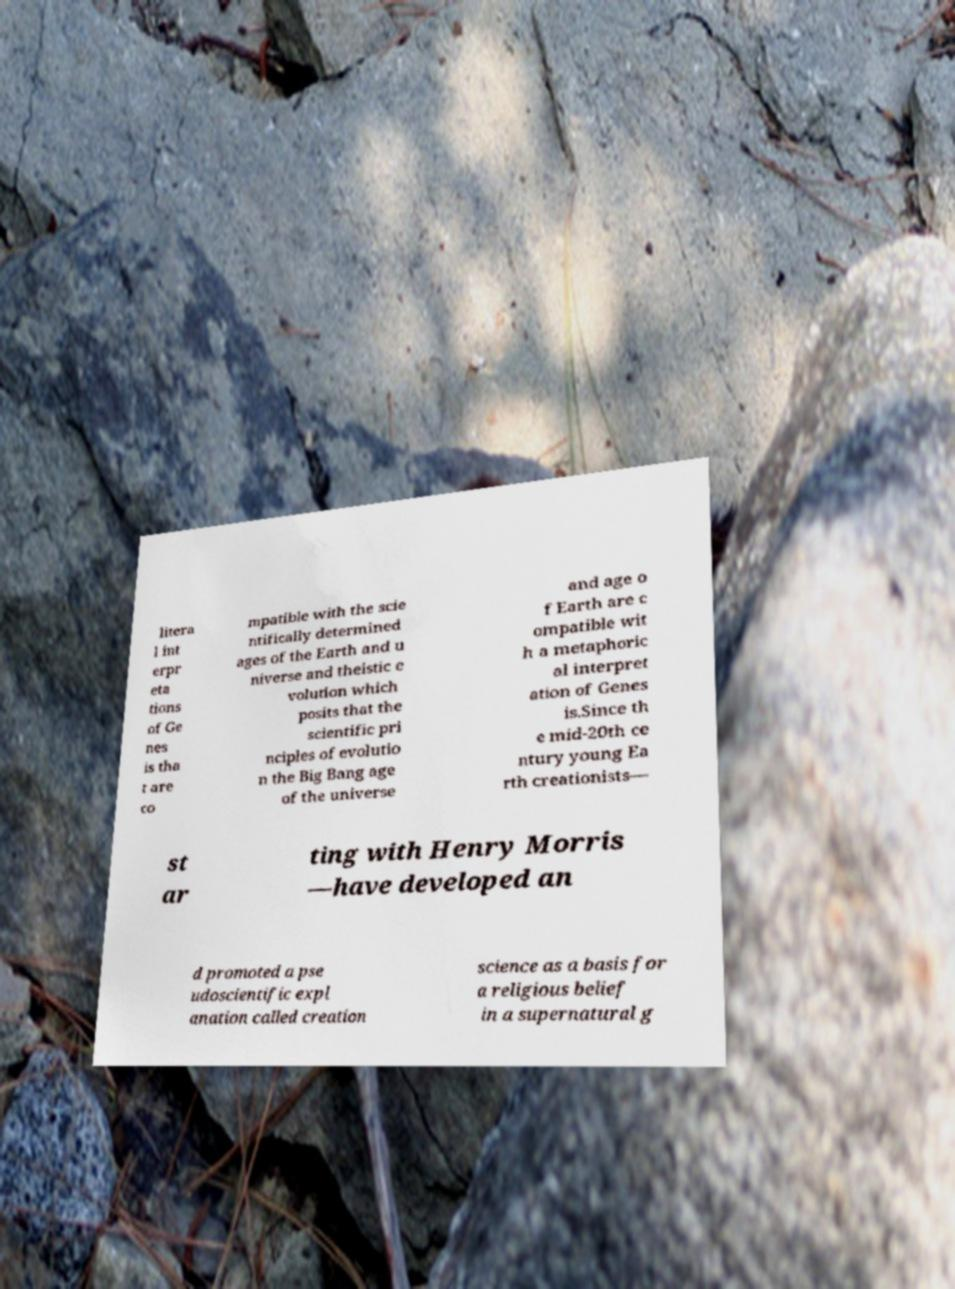There's text embedded in this image that I need extracted. Can you transcribe it verbatim? litera l int erpr eta tions of Ge nes is tha t are co mpatible with the scie ntifically determined ages of the Earth and u niverse and theistic e volution which posits that the scientific pri nciples of evolutio n the Big Bang age of the universe and age o f Earth are c ompatible wit h a metaphoric al interpret ation of Genes is.Since th e mid-20th ce ntury young Ea rth creationists— st ar ting with Henry Morris —have developed an d promoted a pse udoscientific expl anation called creation science as a basis for a religious belief in a supernatural g 